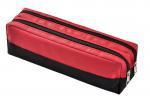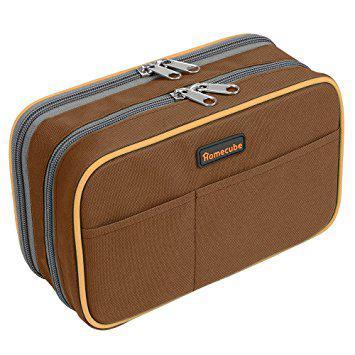The first image is the image on the left, the second image is the image on the right. For the images shown, is this caption "Both images have a pencil box that is flat." true? Answer yes or no. No. The first image is the image on the left, the second image is the image on the right. Given the left and right images, does the statement "Each image contains a single closed pencil case, and at least one case is a solid color with contrasting zipper." hold true? Answer yes or no. Yes. 